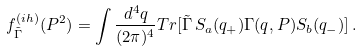Convert formula to latex. <formula><loc_0><loc_0><loc_500><loc_500>f ^ { ( i h ) } _ { \tilde { \Gamma } } ( P ^ { 2 } ) = \int \frac { d ^ { 4 } q } { ( 2 \pi ) ^ { 4 } } T r [ \tilde { \Gamma } \, S _ { a } ( q _ { + } ) \Gamma ( q , P ) S _ { b } ( q _ { - } ) ] \, .</formula> 